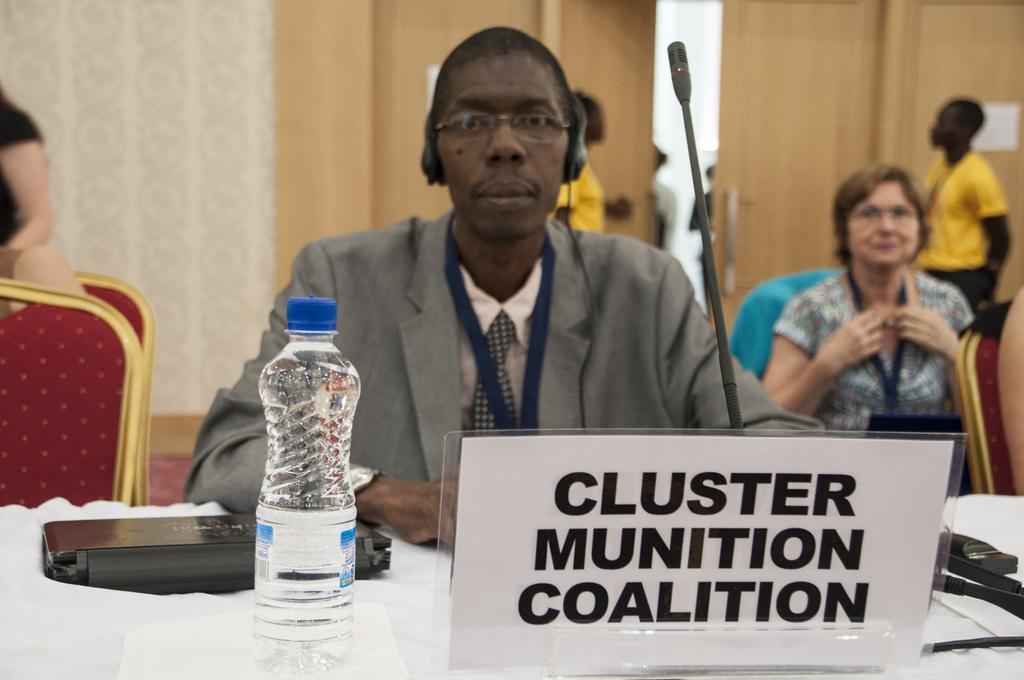In one or two sentences, can you explain what this image depicts? This image is taken indoors. In the background there is a wall with a door and there is a person standing on the floor. At the bottom of the image there is a table with a tablecloth, a name board and a few things on it. On the right side of the image a woman and a person are sitting on the chairs and a man is standing on the floor. In the middle of the image a man is sitting on the chair. On the left side of the image there is an empty chair. A woman is sitting on the chair and another woman is standing on the floor. 